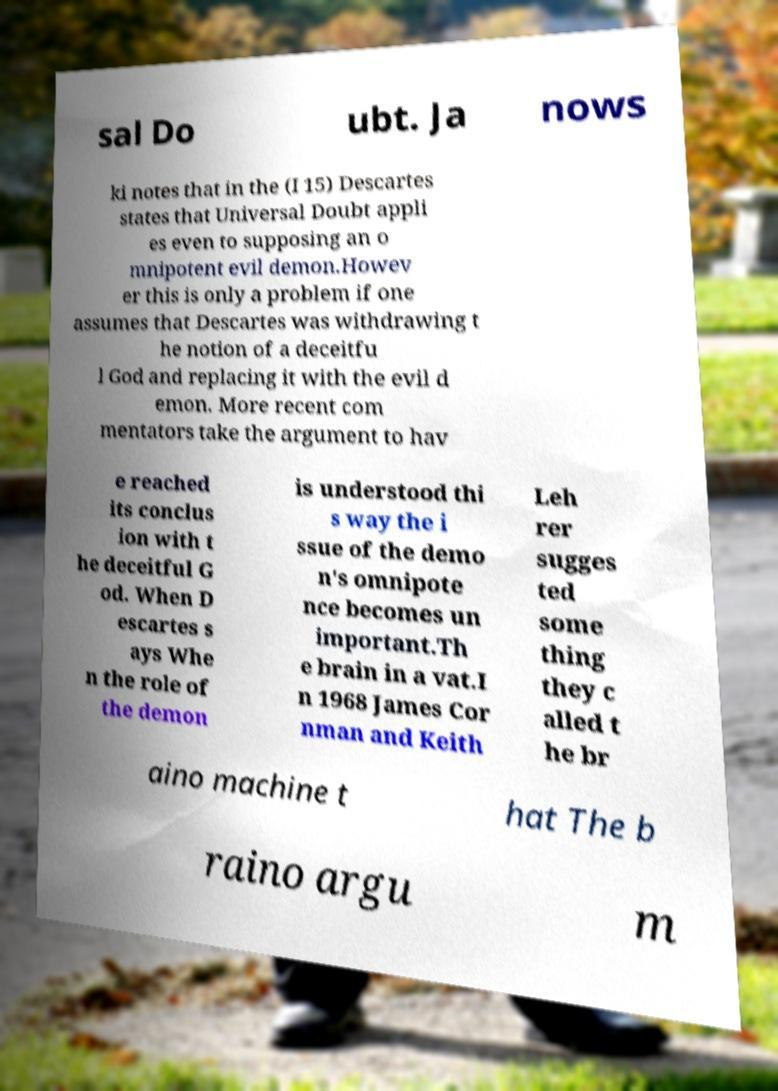For documentation purposes, I need the text within this image transcribed. Could you provide that? sal Do ubt. Ja nows ki notes that in the (I 15) Descartes states that Universal Doubt appli es even to supposing an o mnipotent evil demon.Howev er this is only a problem if one assumes that Descartes was withdrawing t he notion of a deceitfu l God and replacing it with the evil d emon. More recent com mentators take the argument to hav e reached its conclus ion with t he deceitful G od. When D escartes s ays Whe n the role of the demon is understood thi s way the i ssue of the demo n's omnipote nce becomes un important.Th e brain in a vat.I n 1968 James Cor nman and Keith Leh rer sugges ted some thing they c alled t he br aino machine t hat The b raino argu m 